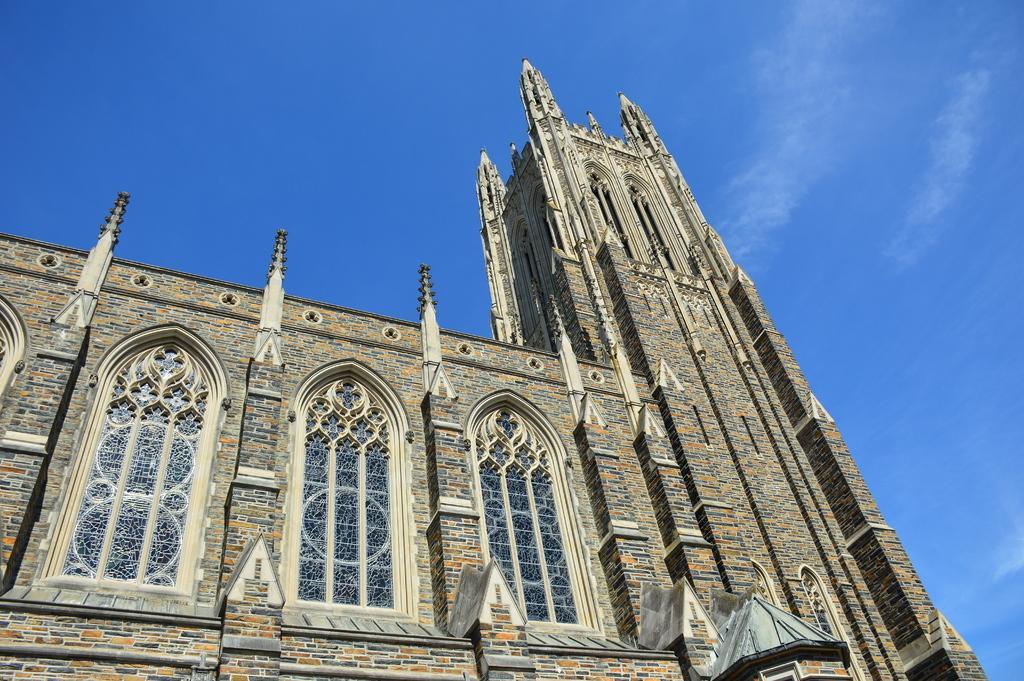In one or two sentences, can you explain what this image depicts? In this picture I can see a building and a blue cloudy sky. 